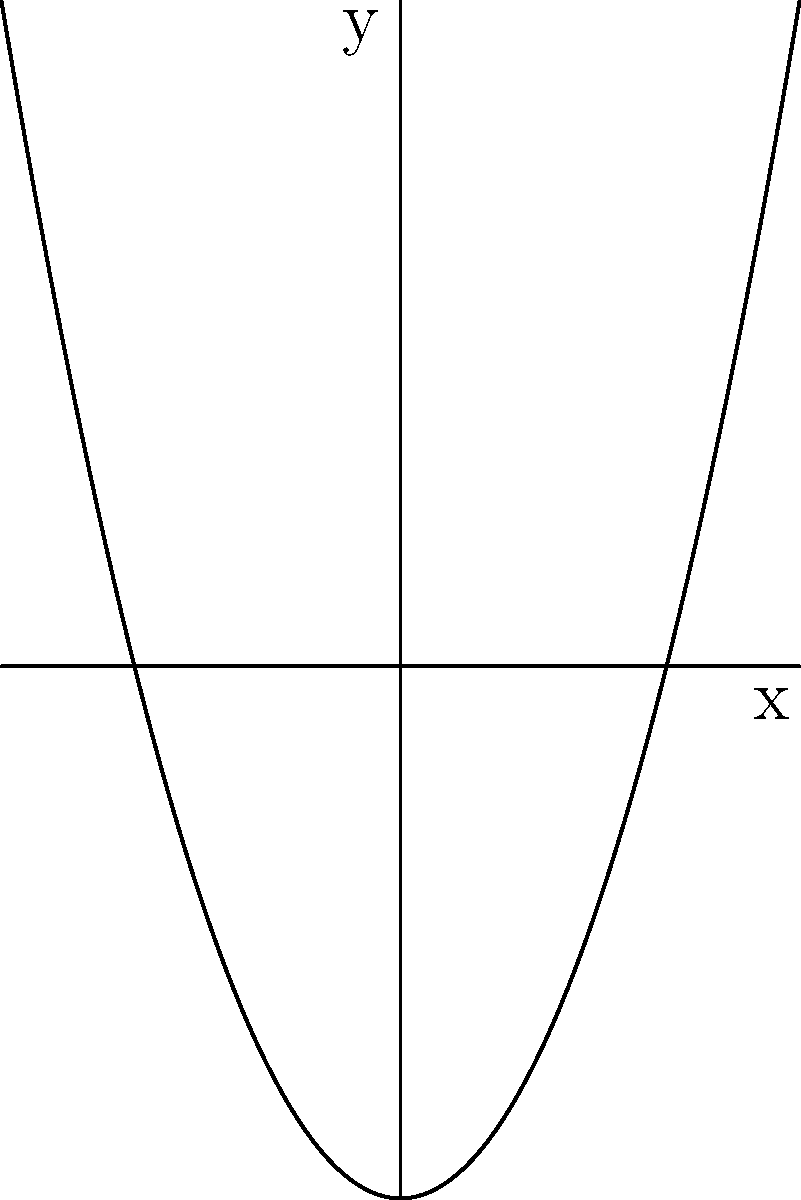In your favorite romantic comedy, the lead characters are planning a surprise party. They decide to use a parabola-shaped banner and a straight line of fairy lights for decoration. The banner follows the equation $y = x^2 - 4$, while the fairy lights are arranged in a line described by $y = 2x + 1$. At what point do the banner and fairy lights intersect? Find the coordinates of this intersection point. Let's approach this step-by-step:

1) We need to find where the parabola $y = x^2 - 4$ intersects with the line $y = 2x + 1$.

2) At the intersection point, the y-values will be equal. So we can set up an equation:
   $x^2 - 4 = 2x + 1$

3) Rearrange the equation:
   $x^2 - 2x - 5 = 0$

4) This is a quadratic equation. We can solve it using the quadratic formula:
   $x = \frac{-b \pm \sqrt{b^2 - 4ac}}{2a}$

   Where $a = 1$, $b = -2$, and $c = -5$

5) Plugging in these values:
   $x = \frac{2 \pm \sqrt{(-2)^2 - 4(1)(-5)}}{2(1)}$
   $= \frac{2 \pm \sqrt{4 + 20}}{2}$
   $= \frac{2 \pm \sqrt{24}}{2}$
   $= \frac{2 \pm 2\sqrt{6}}{2}$

6) This gives us two solutions:
   $x_1 = 1 + \sqrt{6}$ and $x_2 = 1 - \sqrt{6}$

7) However, looking at the graph, we can see that only one of these solutions is in the first quadrant where both x and y are positive. This is $x = 1$.

8) To find the y-coordinate, we can plug x = 1 into either of our original equations. Let's use the line equation:
   $y = 2(1) + 1 = 3$

Therefore, the point of intersection is (1, 3).
Answer: (1, 3) 